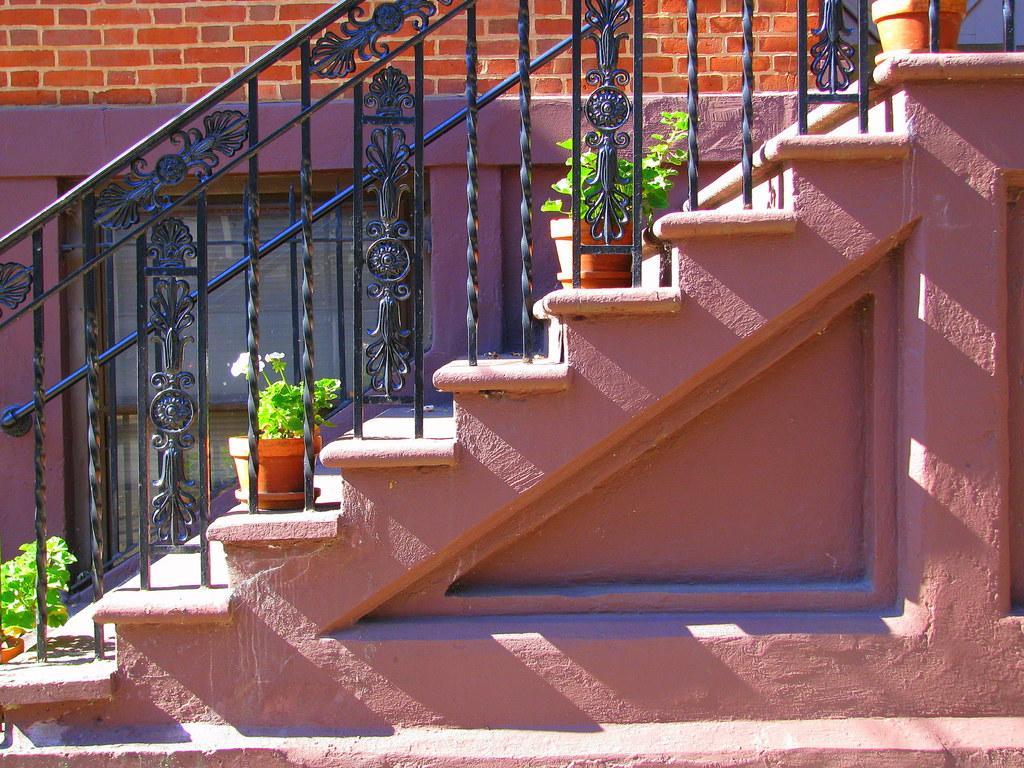Can you describe this image briefly? In this picture we can see a staircase and iron grilles. There are plants in the flower pots. Behind the iron grilles, there is a wall with a window. 